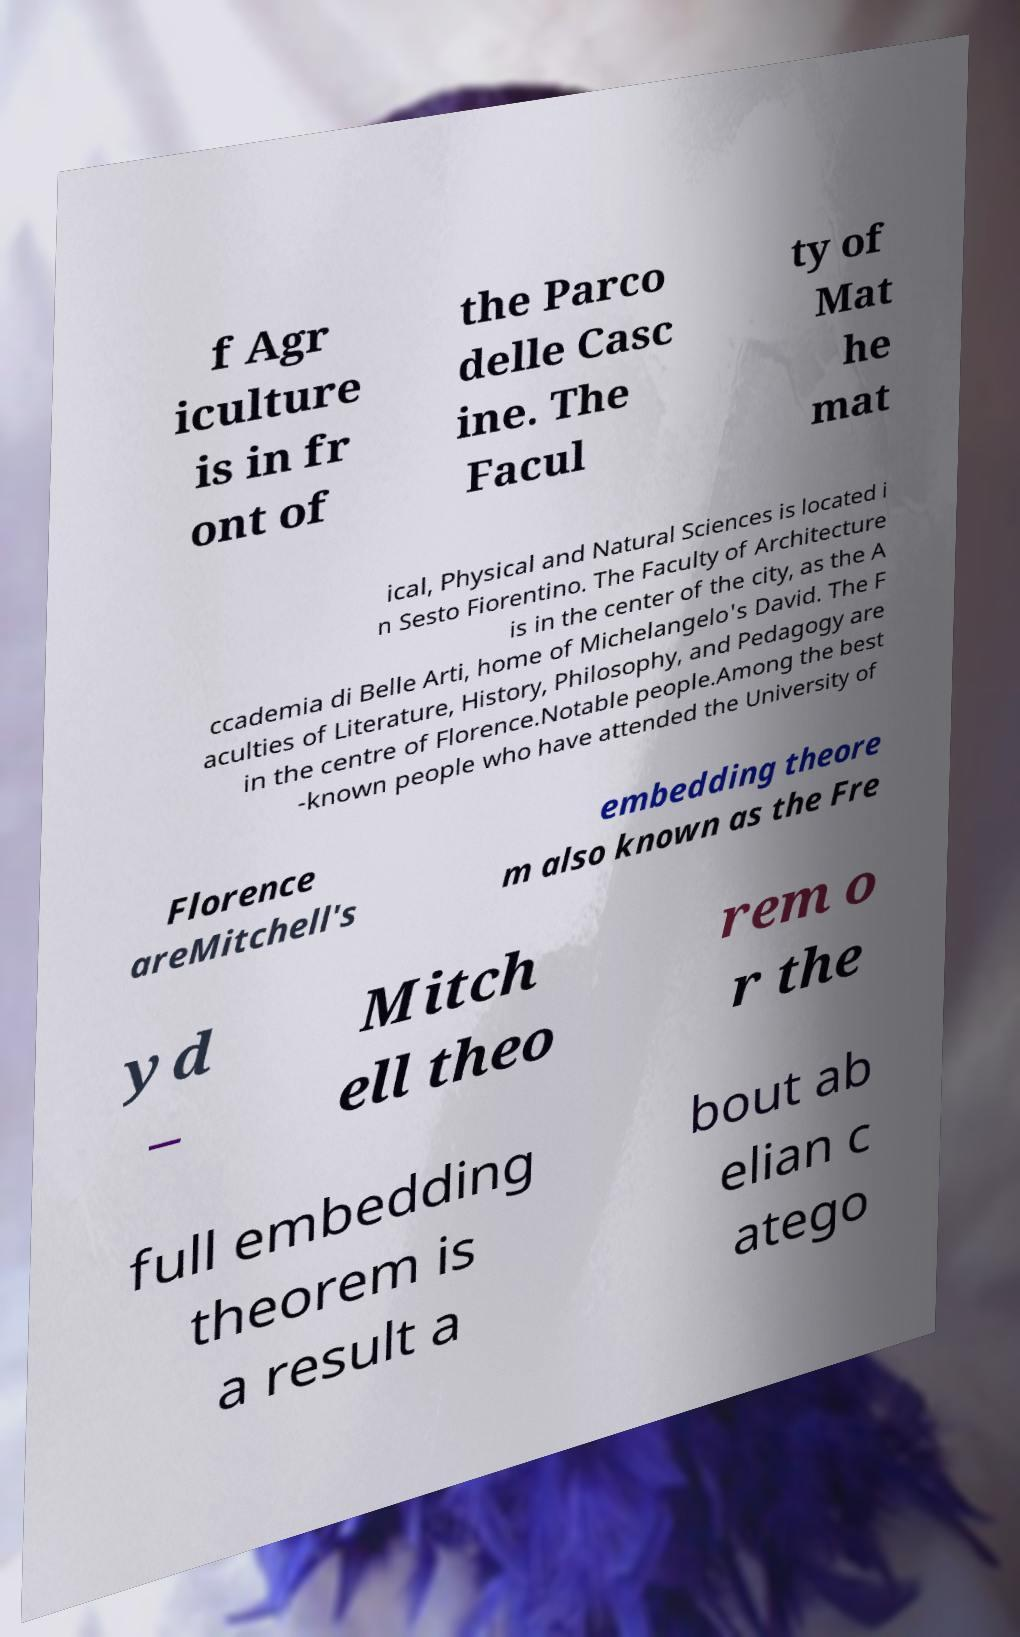For documentation purposes, I need the text within this image transcribed. Could you provide that? f Agr iculture is in fr ont of the Parco delle Casc ine. The Facul ty of Mat he mat ical, Physical and Natural Sciences is located i n Sesto Fiorentino. The Faculty of Architecture is in the center of the city, as the A ccademia di Belle Arti, home of Michelangelo's David. The F aculties of Literature, History, Philosophy, and Pedagogy are in the centre of Florence.Notable people.Among the best -known people who have attended the University of Florence areMitchell's embedding theore m also known as the Fre yd – Mitch ell theo rem o r the full embedding theorem is a result a bout ab elian c atego 